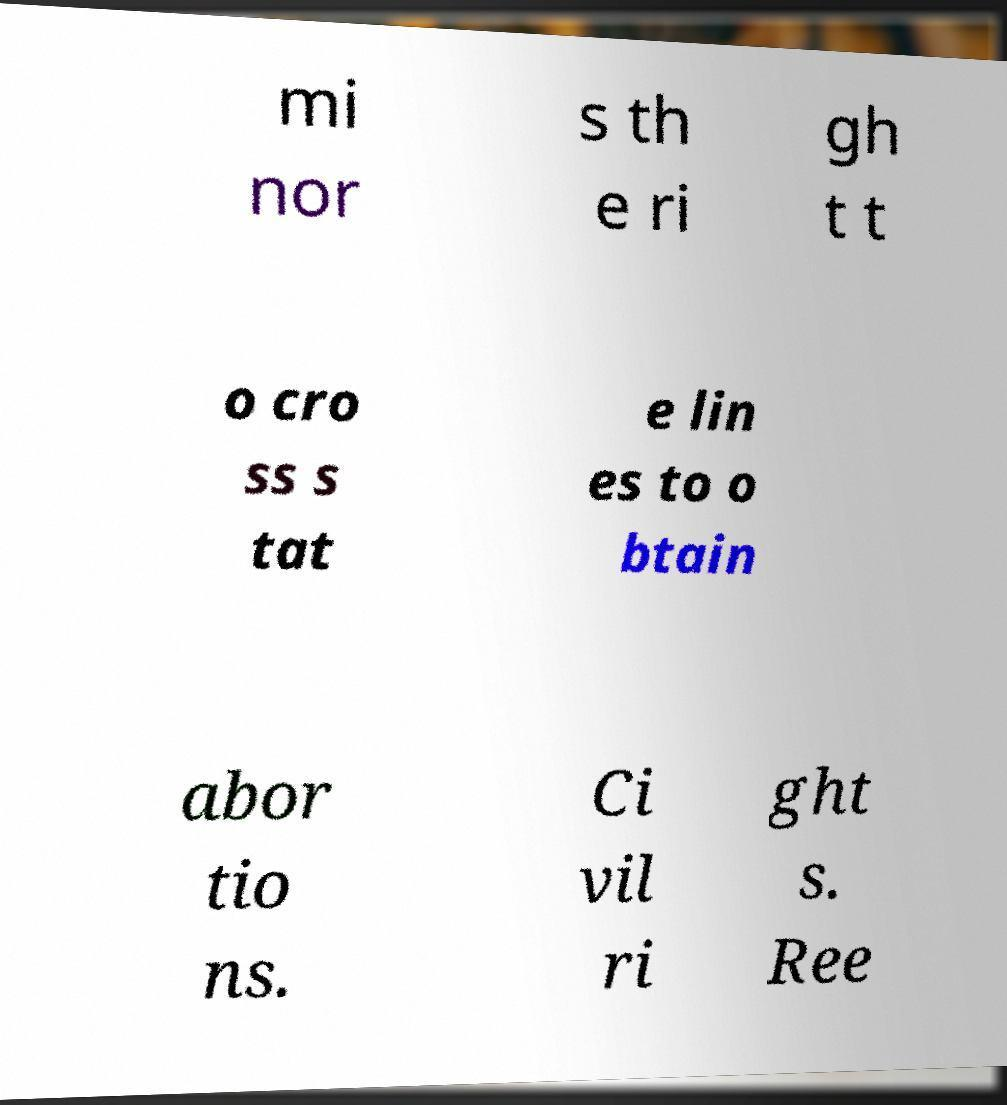There's text embedded in this image that I need extracted. Can you transcribe it verbatim? mi nor s th e ri gh t t o cro ss s tat e lin es to o btain abor tio ns. Ci vil ri ght s. Ree 